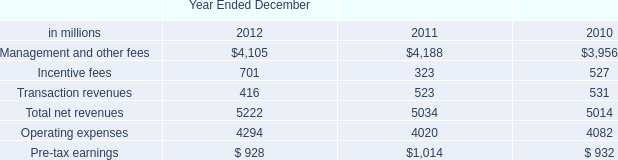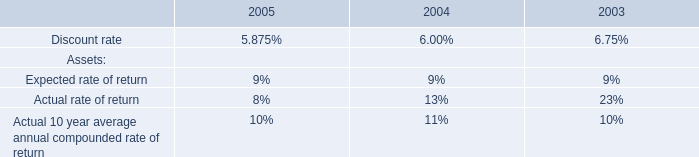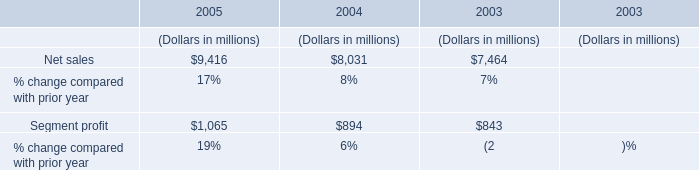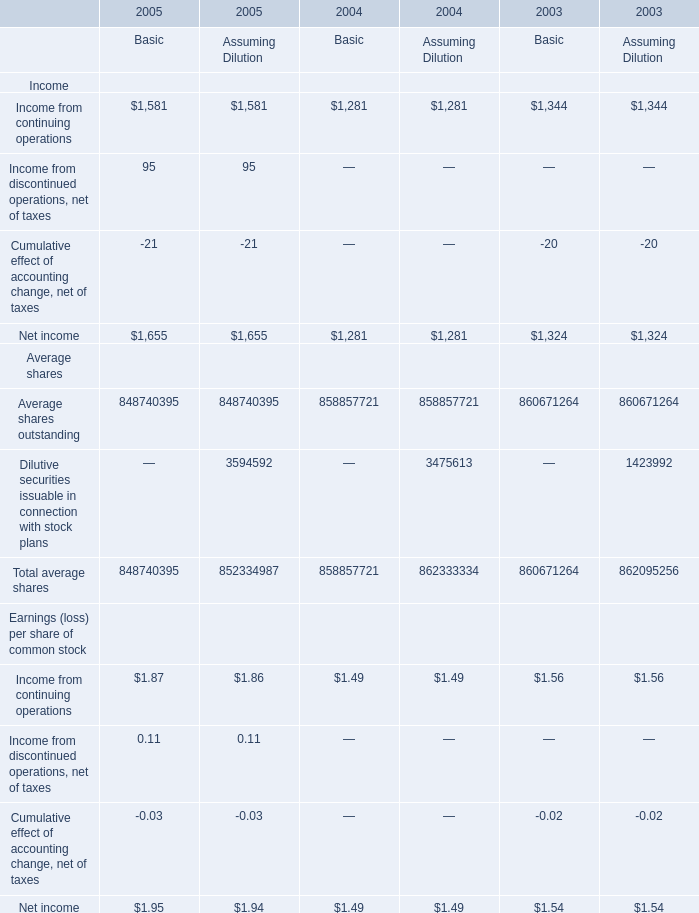If Income from continuing operations for Basic develops with the same increasing rate in 2005, what will it reach in 2006? 
Computations: ((1 + ((1581 - 1281) / 1281)) * 1581)
Answer: 1951.25761. 